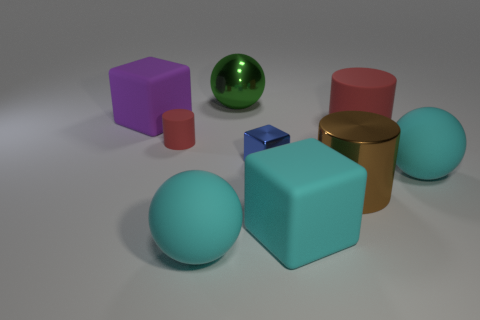Subtract all balls. How many objects are left? 6 Subtract all small matte objects. Subtract all metal blocks. How many objects are left? 7 Add 4 tiny cubes. How many tiny cubes are left? 5 Add 1 large cyan rubber spheres. How many large cyan rubber spheres exist? 3 Subtract 0 gray balls. How many objects are left? 9 